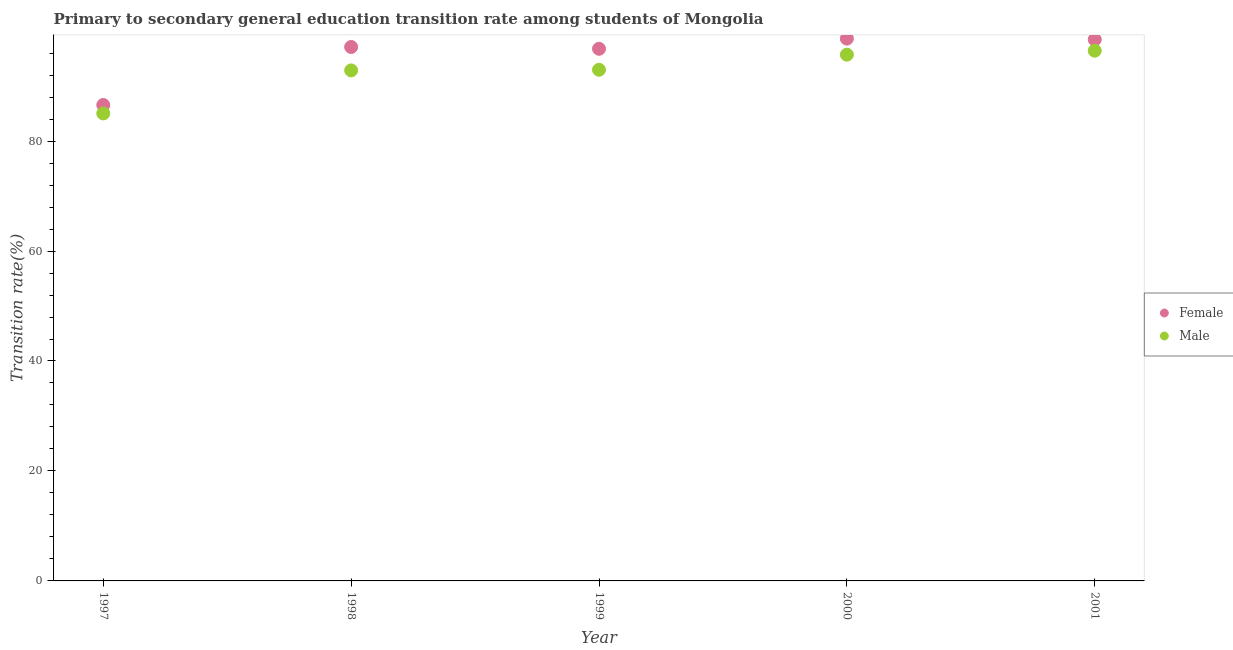Is the number of dotlines equal to the number of legend labels?
Your answer should be very brief. Yes. What is the transition rate among female students in 1997?
Make the answer very short. 86.56. Across all years, what is the maximum transition rate among female students?
Give a very brief answer. 98.64. Across all years, what is the minimum transition rate among male students?
Keep it short and to the point. 85.03. In which year was the transition rate among male students maximum?
Provide a short and direct response. 2001. In which year was the transition rate among female students minimum?
Your answer should be very brief. 1997. What is the total transition rate among female students in the graph?
Your response must be concise. 477.57. What is the difference between the transition rate among female students in 1998 and that in 2000?
Offer a terse response. -1.52. What is the difference between the transition rate among female students in 2001 and the transition rate among male students in 2000?
Your answer should be very brief. 2.76. What is the average transition rate among female students per year?
Your response must be concise. 95.51. In the year 1997, what is the difference between the transition rate among female students and transition rate among male students?
Make the answer very short. 1.53. In how many years, is the transition rate among male students greater than 80 %?
Make the answer very short. 5. What is the ratio of the transition rate among female students in 2000 to that in 2001?
Offer a very short reply. 1. Is the transition rate among male students in 1998 less than that in 1999?
Provide a short and direct response. Yes. Is the difference between the transition rate among female students in 1998 and 1999 greater than the difference between the transition rate among male students in 1998 and 1999?
Offer a terse response. Yes. What is the difference between the highest and the second highest transition rate among female students?
Ensure brevity in your answer.  0.16. What is the difference between the highest and the lowest transition rate among male students?
Your answer should be compact. 11.41. Is the sum of the transition rate among female students in 1998 and 1999 greater than the maximum transition rate among male students across all years?
Your answer should be very brief. Yes. Is the transition rate among male students strictly greater than the transition rate among female students over the years?
Your response must be concise. No. Does the graph contain any zero values?
Provide a succinct answer. No. How are the legend labels stacked?
Offer a terse response. Vertical. What is the title of the graph?
Your response must be concise. Primary to secondary general education transition rate among students of Mongolia. Does "Largest city" appear as one of the legend labels in the graph?
Your answer should be compact. No. What is the label or title of the X-axis?
Make the answer very short. Year. What is the label or title of the Y-axis?
Offer a very short reply. Transition rate(%). What is the Transition rate(%) of Female in 1997?
Ensure brevity in your answer.  86.56. What is the Transition rate(%) of Male in 1997?
Make the answer very short. 85.03. What is the Transition rate(%) in Female in 1998?
Offer a terse response. 97.11. What is the Transition rate(%) in Male in 1998?
Ensure brevity in your answer.  92.85. What is the Transition rate(%) of Female in 1999?
Provide a short and direct response. 96.79. What is the Transition rate(%) of Male in 1999?
Keep it short and to the point. 92.97. What is the Transition rate(%) of Female in 2000?
Ensure brevity in your answer.  98.64. What is the Transition rate(%) in Male in 2000?
Offer a very short reply. 95.71. What is the Transition rate(%) of Female in 2001?
Provide a succinct answer. 98.47. What is the Transition rate(%) of Male in 2001?
Ensure brevity in your answer.  96.44. Across all years, what is the maximum Transition rate(%) of Female?
Your answer should be very brief. 98.64. Across all years, what is the maximum Transition rate(%) of Male?
Provide a succinct answer. 96.44. Across all years, what is the minimum Transition rate(%) of Female?
Your answer should be compact. 86.56. Across all years, what is the minimum Transition rate(%) in Male?
Make the answer very short. 85.03. What is the total Transition rate(%) in Female in the graph?
Ensure brevity in your answer.  477.57. What is the total Transition rate(%) in Male in the graph?
Offer a very short reply. 463.01. What is the difference between the Transition rate(%) of Female in 1997 and that in 1998?
Keep it short and to the point. -10.55. What is the difference between the Transition rate(%) of Male in 1997 and that in 1998?
Provide a short and direct response. -7.82. What is the difference between the Transition rate(%) in Female in 1997 and that in 1999?
Provide a succinct answer. -10.22. What is the difference between the Transition rate(%) of Male in 1997 and that in 1999?
Provide a short and direct response. -7.94. What is the difference between the Transition rate(%) in Female in 1997 and that in 2000?
Provide a succinct answer. -12.07. What is the difference between the Transition rate(%) in Male in 1997 and that in 2000?
Provide a short and direct response. -10.68. What is the difference between the Transition rate(%) of Female in 1997 and that in 2001?
Offer a terse response. -11.91. What is the difference between the Transition rate(%) in Male in 1997 and that in 2001?
Provide a succinct answer. -11.41. What is the difference between the Transition rate(%) in Female in 1998 and that in 1999?
Offer a terse response. 0.33. What is the difference between the Transition rate(%) of Male in 1998 and that in 1999?
Give a very brief answer. -0.12. What is the difference between the Transition rate(%) in Female in 1998 and that in 2000?
Your answer should be very brief. -1.52. What is the difference between the Transition rate(%) of Male in 1998 and that in 2000?
Offer a terse response. -2.86. What is the difference between the Transition rate(%) of Female in 1998 and that in 2001?
Keep it short and to the point. -1.36. What is the difference between the Transition rate(%) of Male in 1998 and that in 2001?
Give a very brief answer. -3.59. What is the difference between the Transition rate(%) in Female in 1999 and that in 2000?
Keep it short and to the point. -1.85. What is the difference between the Transition rate(%) in Male in 1999 and that in 2000?
Your response must be concise. -2.74. What is the difference between the Transition rate(%) in Female in 1999 and that in 2001?
Your response must be concise. -1.68. What is the difference between the Transition rate(%) in Male in 1999 and that in 2001?
Give a very brief answer. -3.47. What is the difference between the Transition rate(%) in Female in 2000 and that in 2001?
Give a very brief answer. 0.16. What is the difference between the Transition rate(%) of Male in 2000 and that in 2001?
Your answer should be very brief. -0.73. What is the difference between the Transition rate(%) in Female in 1997 and the Transition rate(%) in Male in 1998?
Offer a terse response. -6.29. What is the difference between the Transition rate(%) of Female in 1997 and the Transition rate(%) of Male in 1999?
Keep it short and to the point. -6.41. What is the difference between the Transition rate(%) in Female in 1997 and the Transition rate(%) in Male in 2000?
Give a very brief answer. -9.15. What is the difference between the Transition rate(%) of Female in 1997 and the Transition rate(%) of Male in 2001?
Your answer should be very brief. -9.88. What is the difference between the Transition rate(%) of Female in 1998 and the Transition rate(%) of Male in 1999?
Offer a terse response. 4.14. What is the difference between the Transition rate(%) of Female in 1998 and the Transition rate(%) of Male in 2000?
Keep it short and to the point. 1.4. What is the difference between the Transition rate(%) of Female in 1998 and the Transition rate(%) of Male in 2001?
Provide a short and direct response. 0.67. What is the difference between the Transition rate(%) of Female in 1999 and the Transition rate(%) of Male in 2000?
Your answer should be very brief. 1.07. What is the difference between the Transition rate(%) in Female in 1999 and the Transition rate(%) in Male in 2001?
Keep it short and to the point. 0.35. What is the difference between the Transition rate(%) in Female in 2000 and the Transition rate(%) in Male in 2001?
Keep it short and to the point. 2.19. What is the average Transition rate(%) in Female per year?
Your answer should be compact. 95.51. What is the average Transition rate(%) of Male per year?
Offer a very short reply. 92.6. In the year 1997, what is the difference between the Transition rate(%) in Female and Transition rate(%) in Male?
Your answer should be very brief. 1.53. In the year 1998, what is the difference between the Transition rate(%) in Female and Transition rate(%) in Male?
Provide a short and direct response. 4.26. In the year 1999, what is the difference between the Transition rate(%) of Female and Transition rate(%) of Male?
Your response must be concise. 3.81. In the year 2000, what is the difference between the Transition rate(%) of Female and Transition rate(%) of Male?
Offer a terse response. 2.92. In the year 2001, what is the difference between the Transition rate(%) of Female and Transition rate(%) of Male?
Provide a succinct answer. 2.03. What is the ratio of the Transition rate(%) of Female in 1997 to that in 1998?
Your answer should be very brief. 0.89. What is the ratio of the Transition rate(%) in Male in 1997 to that in 1998?
Keep it short and to the point. 0.92. What is the ratio of the Transition rate(%) in Female in 1997 to that in 1999?
Keep it short and to the point. 0.89. What is the ratio of the Transition rate(%) of Male in 1997 to that in 1999?
Give a very brief answer. 0.91. What is the ratio of the Transition rate(%) in Female in 1997 to that in 2000?
Provide a short and direct response. 0.88. What is the ratio of the Transition rate(%) in Male in 1997 to that in 2000?
Give a very brief answer. 0.89. What is the ratio of the Transition rate(%) in Female in 1997 to that in 2001?
Your response must be concise. 0.88. What is the ratio of the Transition rate(%) of Male in 1997 to that in 2001?
Keep it short and to the point. 0.88. What is the ratio of the Transition rate(%) in Female in 1998 to that in 1999?
Offer a very short reply. 1. What is the ratio of the Transition rate(%) of Male in 1998 to that in 1999?
Your response must be concise. 1. What is the ratio of the Transition rate(%) in Female in 1998 to that in 2000?
Provide a short and direct response. 0.98. What is the ratio of the Transition rate(%) in Male in 1998 to that in 2000?
Keep it short and to the point. 0.97. What is the ratio of the Transition rate(%) of Female in 1998 to that in 2001?
Keep it short and to the point. 0.99. What is the ratio of the Transition rate(%) of Male in 1998 to that in 2001?
Make the answer very short. 0.96. What is the ratio of the Transition rate(%) of Female in 1999 to that in 2000?
Offer a terse response. 0.98. What is the ratio of the Transition rate(%) in Male in 1999 to that in 2000?
Offer a terse response. 0.97. What is the ratio of the Transition rate(%) in Female in 1999 to that in 2001?
Make the answer very short. 0.98. What is the ratio of the Transition rate(%) of Male in 1999 to that in 2001?
Offer a very short reply. 0.96. What is the ratio of the Transition rate(%) of Male in 2000 to that in 2001?
Provide a succinct answer. 0.99. What is the difference between the highest and the second highest Transition rate(%) in Female?
Offer a very short reply. 0.16. What is the difference between the highest and the second highest Transition rate(%) in Male?
Keep it short and to the point. 0.73. What is the difference between the highest and the lowest Transition rate(%) of Female?
Ensure brevity in your answer.  12.07. What is the difference between the highest and the lowest Transition rate(%) in Male?
Your answer should be very brief. 11.41. 